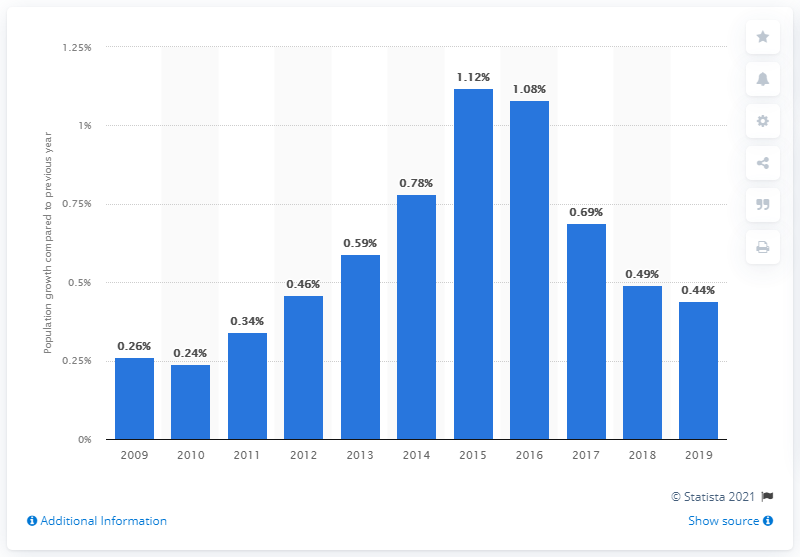Give some essential details in this illustration. The population of Austria increased by 0.44% in 2019. 